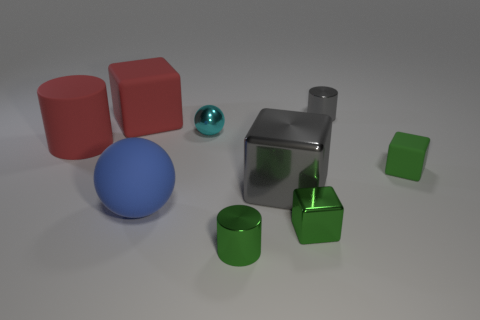What is the color of the metal cube that is the same size as the blue rubber sphere?
Your answer should be compact. Gray. There is a big shiny block; is it the same color as the matte thing that is on the left side of the big matte cube?
Your answer should be compact. No. There is a cylinder that is behind the rubber cube that is left of the large gray metallic cube; what is its material?
Ensure brevity in your answer.  Metal. How many shiny objects are both on the right side of the large gray metallic object and in front of the small gray thing?
Provide a succinct answer. 1. What number of other objects are the same size as the green rubber block?
Give a very brief answer. 4. Is the shape of the big thing that is right of the tiny green cylinder the same as the large matte object on the right side of the red block?
Your answer should be very brief. No. There is a gray metal block; are there any green blocks in front of it?
Keep it short and to the point. Yes. What color is the small metallic thing that is the same shape as the blue rubber object?
Keep it short and to the point. Cyan. Is there anything else that has the same shape as the small rubber object?
Make the answer very short. Yes. What is the tiny cylinder behind the matte sphere made of?
Keep it short and to the point. Metal. 